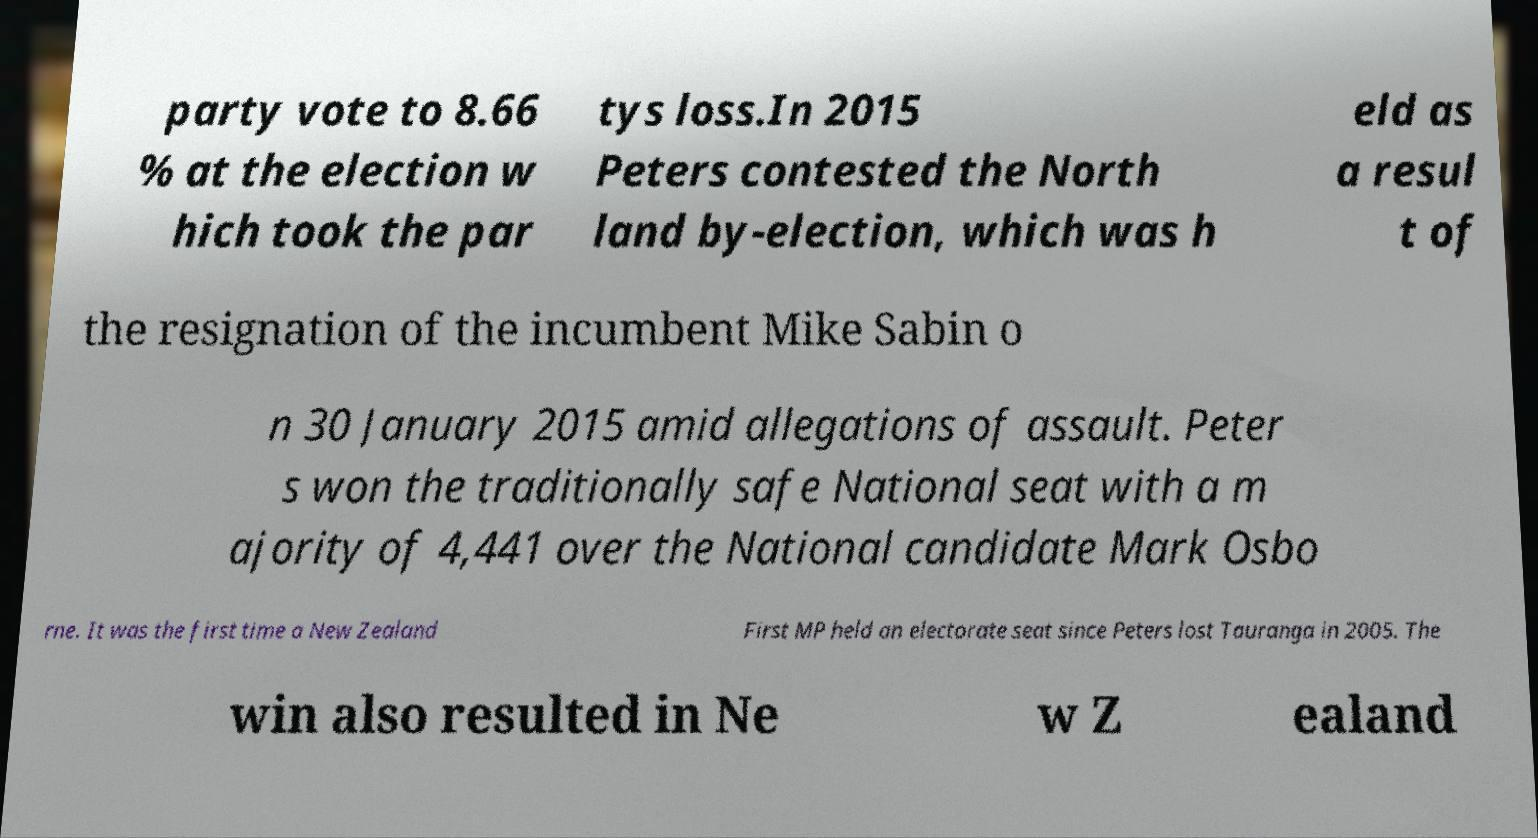Please identify and transcribe the text found in this image. party vote to 8.66 % at the election w hich took the par tys loss.In 2015 Peters contested the North land by-election, which was h eld as a resul t of the resignation of the incumbent Mike Sabin o n 30 January 2015 amid allegations of assault. Peter s won the traditionally safe National seat with a m ajority of 4,441 over the National candidate Mark Osbo rne. It was the first time a New Zealand First MP held an electorate seat since Peters lost Tauranga in 2005. The win also resulted in Ne w Z ealand 